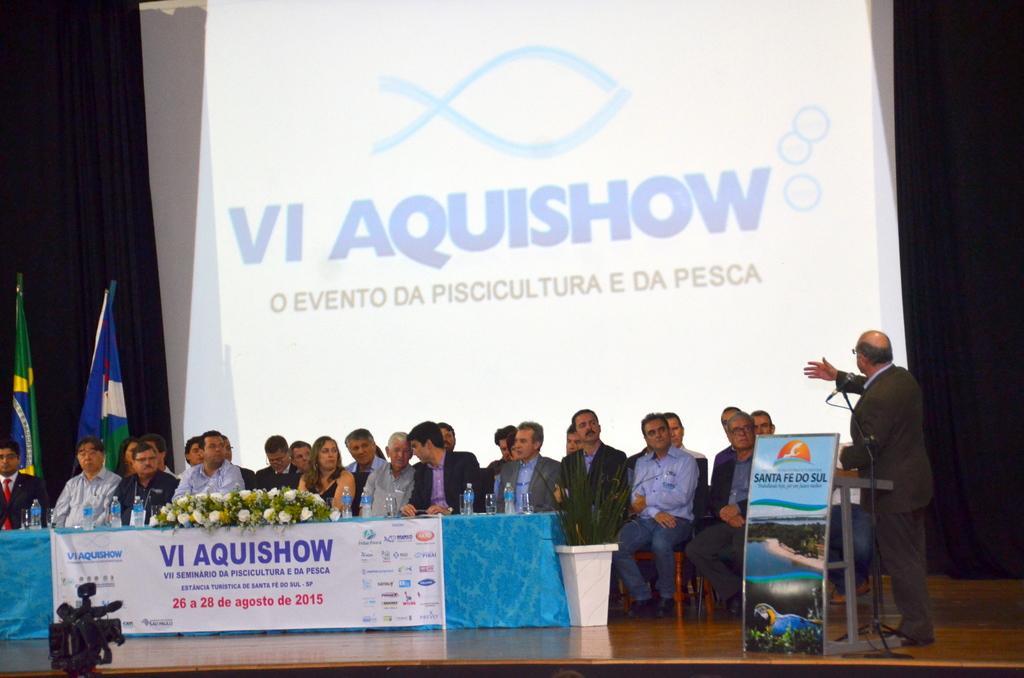Could you give a brief overview of what you see in this image? This picture is taken on the stage. On the stage, there are group of people sitting on the chairs, behind the table. On the table, there are flowers and bottles towards the left. Towards the right, there is a man standing at the podium, he is wearing a blazer and trousers. In the background, there is a screen with some text. Towards the left, there are two flags with different colors. At the bottom left, there is a camera. 